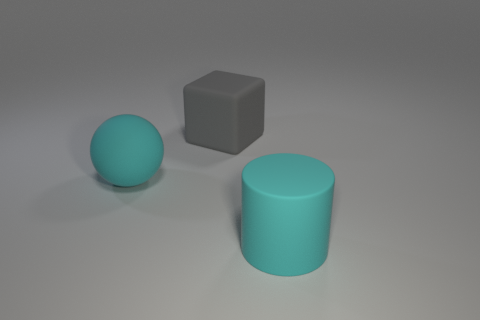How big is the gray rubber cube?
Your answer should be very brief. Large. What is the large gray object made of?
Offer a terse response. Rubber. There is a thing that is right of the gray block; is its size the same as the gray cube?
Give a very brief answer. Yes. How many things are either matte objects or cyan matte things?
Make the answer very short. 3. There is a large matte object that is the same color as the large ball; what shape is it?
Provide a succinct answer. Cylinder. What size is the rubber object that is in front of the large block and to the right of the large sphere?
Offer a terse response. Large. How many small purple rubber objects are there?
Your response must be concise. 0. What number of blocks are either green rubber objects or cyan rubber things?
Ensure brevity in your answer.  0. What number of gray matte objects are in front of the cyan thing that is behind the object to the right of the gray block?
Offer a terse response. 0. What is the color of the matte cylinder that is the same size as the gray matte object?
Your answer should be very brief. Cyan. 